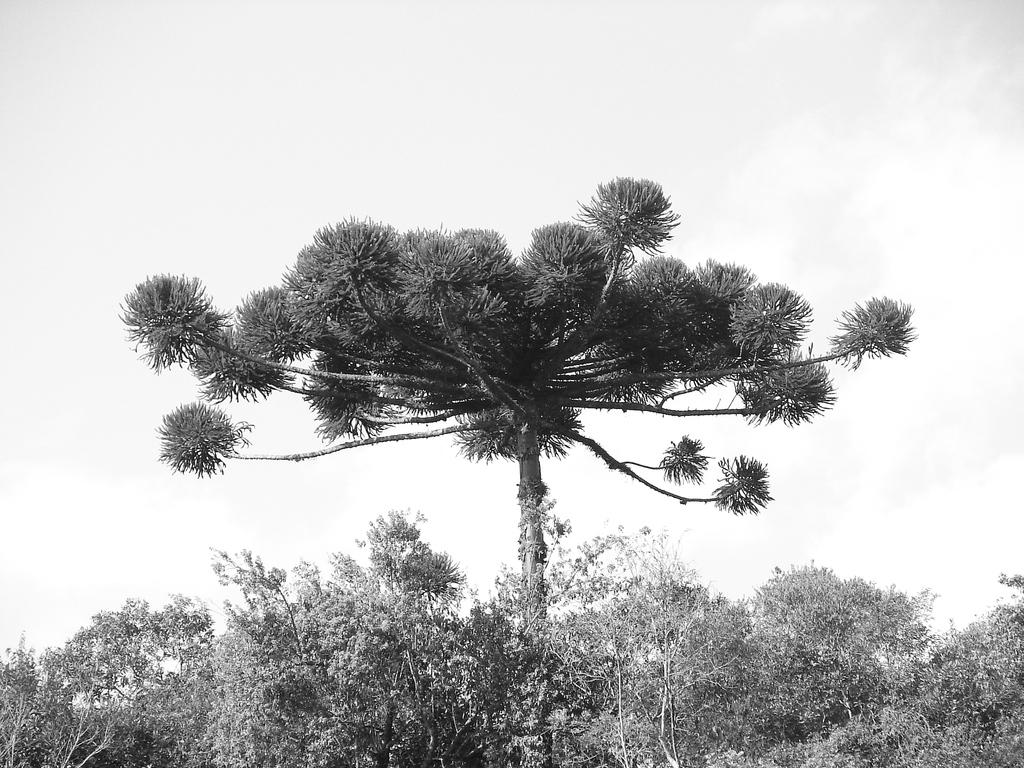What type of vegetation can be seen in the image? There are trees in the image. What part of the natural environment is visible in the image? The sky is visible in the background of the image. What type of basketball game is being played in the image? There is no basketball game present in the image; it features trees and the sky. Who is the partner of the person in the image? There is no person present in the image, so it is not possible to determine who their partner might be. 